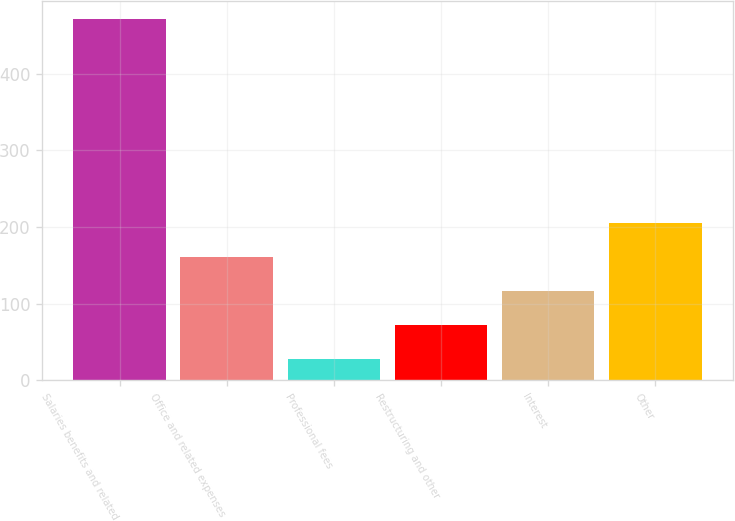Convert chart to OTSL. <chart><loc_0><loc_0><loc_500><loc_500><bar_chart><fcel>Salaries benefits and related<fcel>Office and related expenses<fcel>Professional fees<fcel>Restructuring and other<fcel>Interest<fcel>Other<nl><fcel>471.9<fcel>160.96<fcel>27.7<fcel>72.12<fcel>116.54<fcel>205.38<nl></chart> 